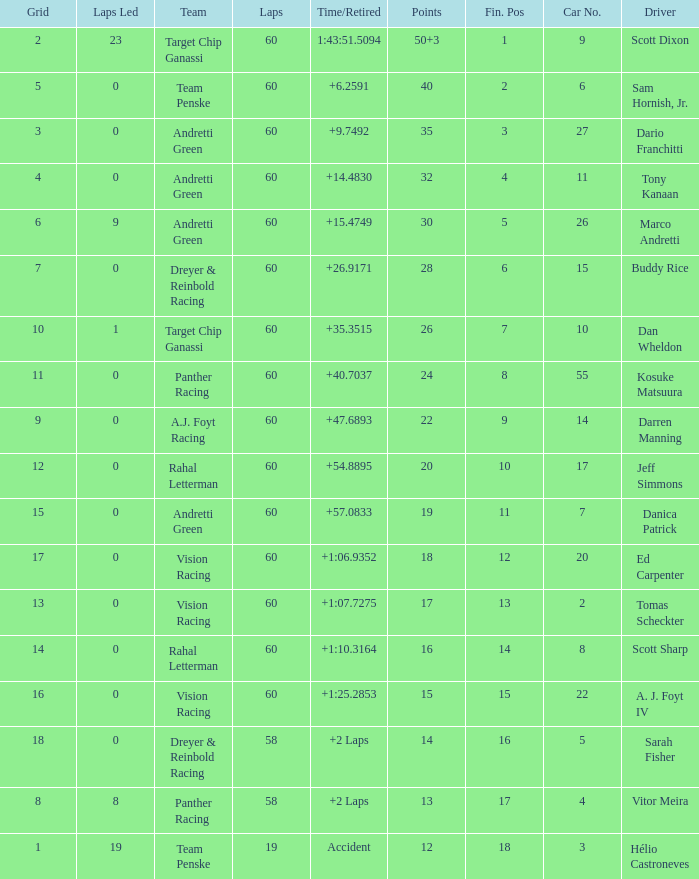What is the motivation for having 13 points? Vitor Meira. 